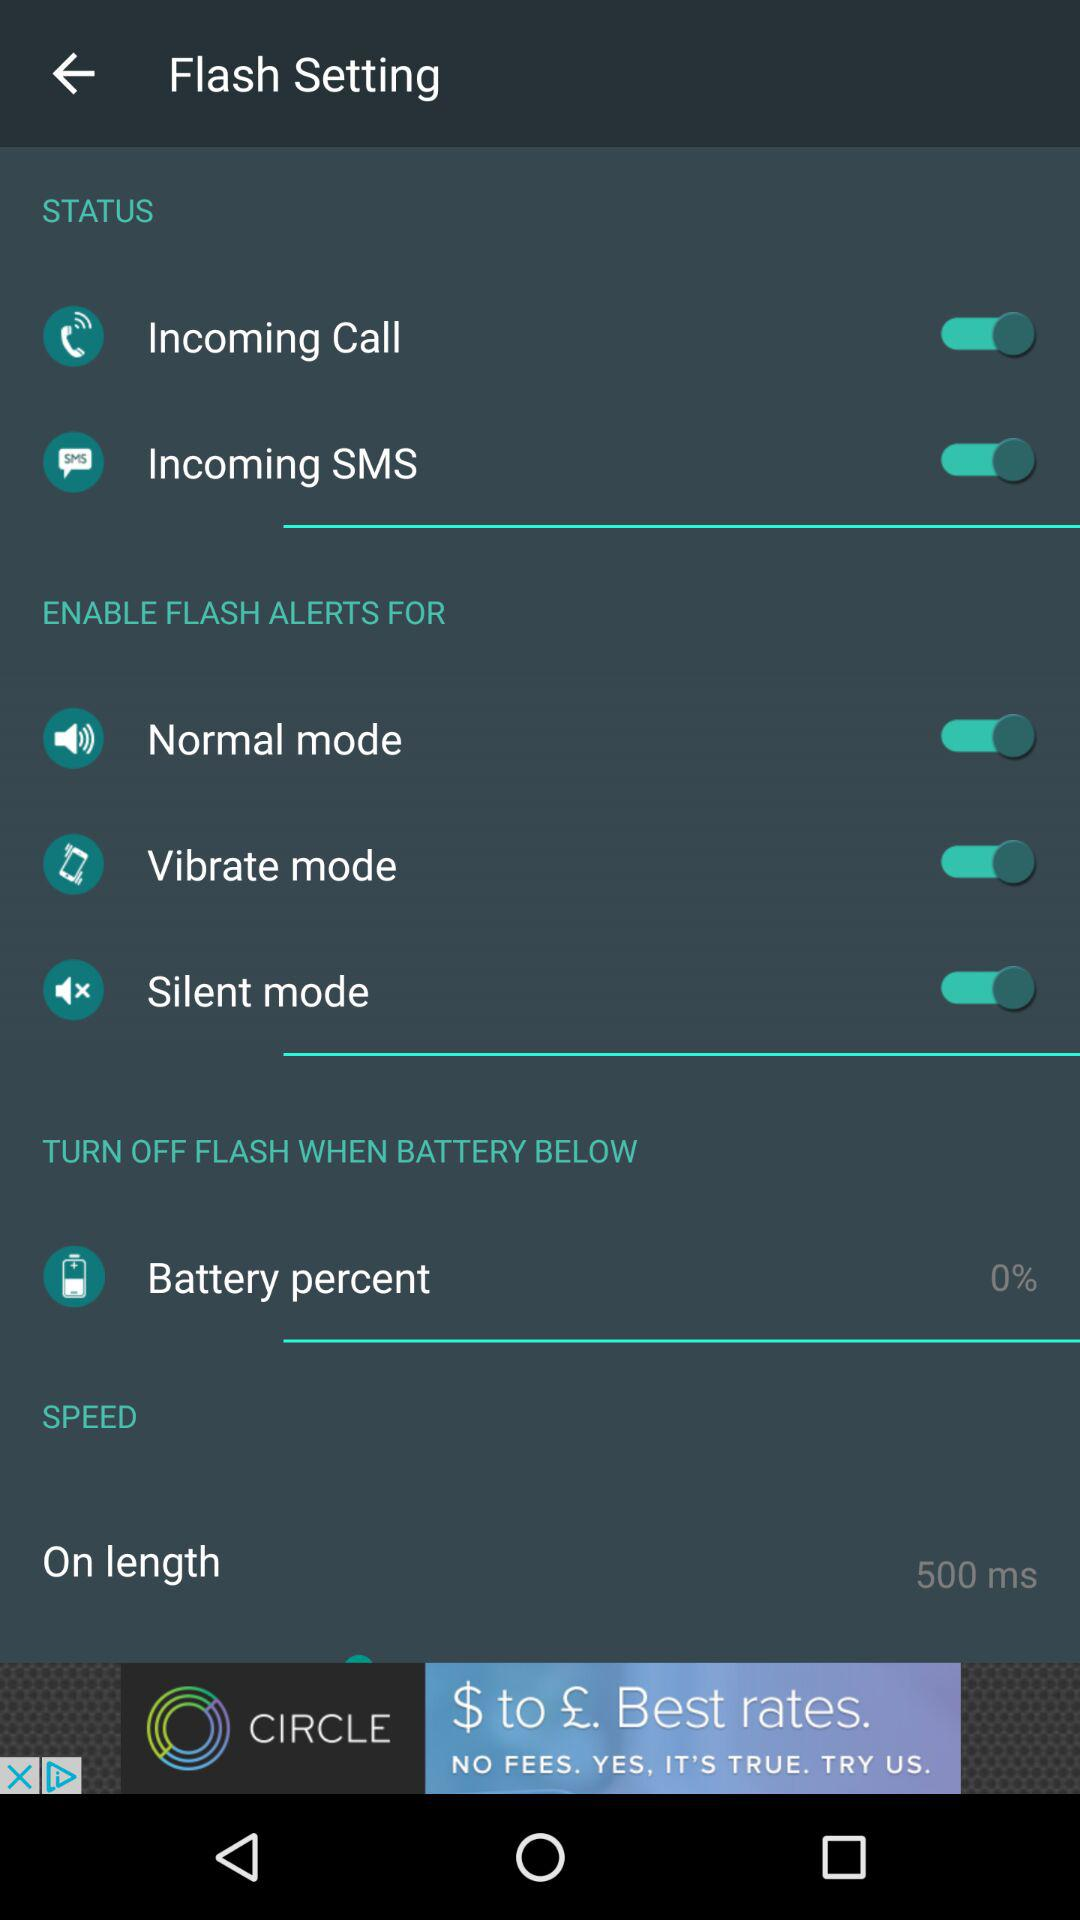What is the name of the application?
When the provided information is insufficient, respond with <no answer>. <no answer> 